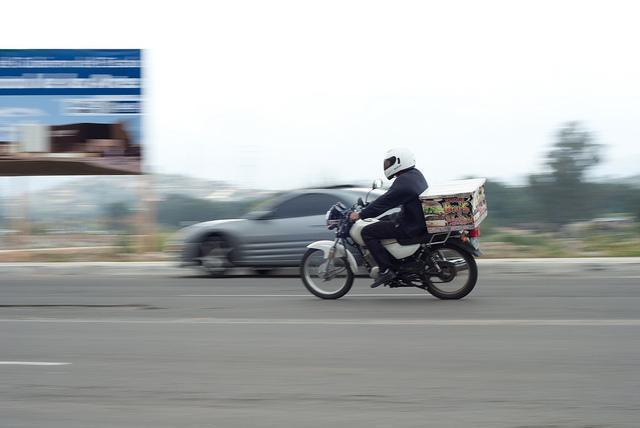How do motorcyclists carry gear?
Choose the right answer from the provided options to respond to the question.
Options: Cart, string, luggage space, donkey. Luggage space. 